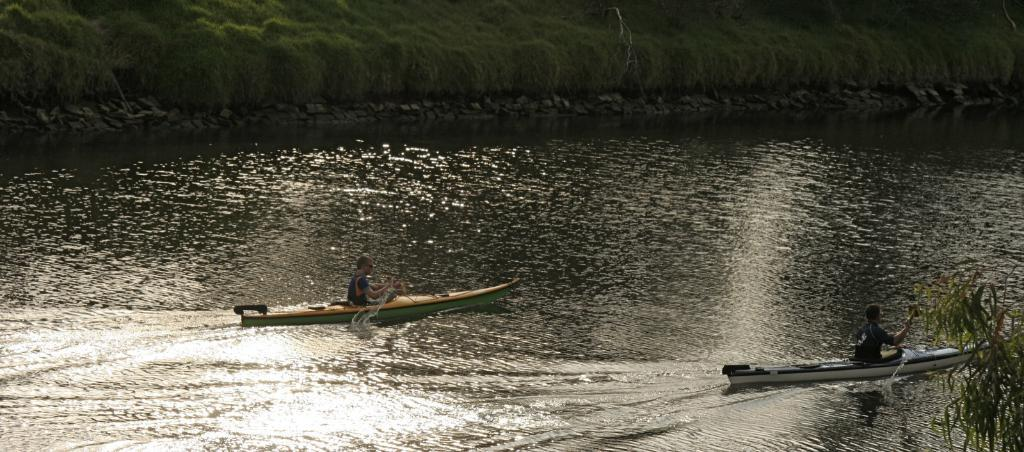How many people are in the image? There are two people in the image. What are the people doing in the image? The people are sitting on boats. What is the primary setting of the image? There is water visible in the image. What can be seen in the background of the image? There are trees in the background of the image. What rule is being enforced by the hand in the image? There is no hand present in the image, and therefore no rule can be enforced. What is the aftermath of the event depicted in the image? The image does not depict an event, so there is no aftermath to describe. 